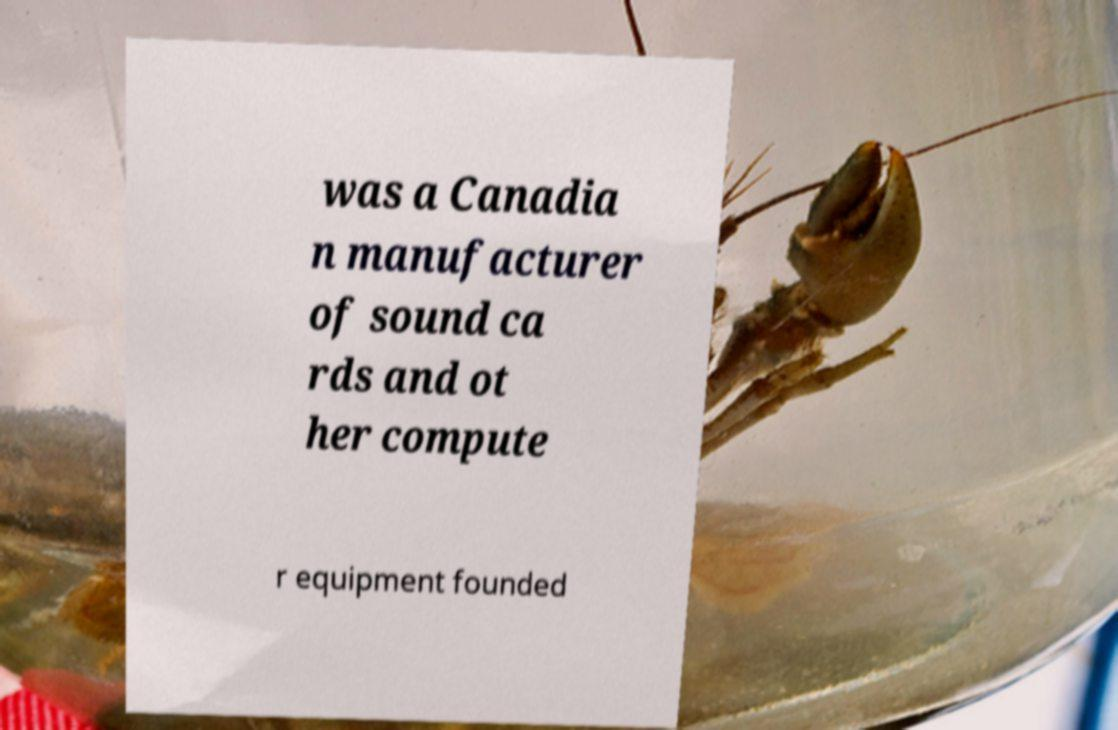Could you assist in decoding the text presented in this image and type it out clearly? was a Canadia n manufacturer of sound ca rds and ot her compute r equipment founded 